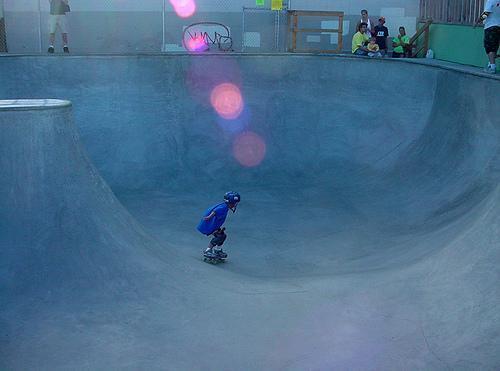How many people are skateboarding?
Give a very brief answer. 1. 